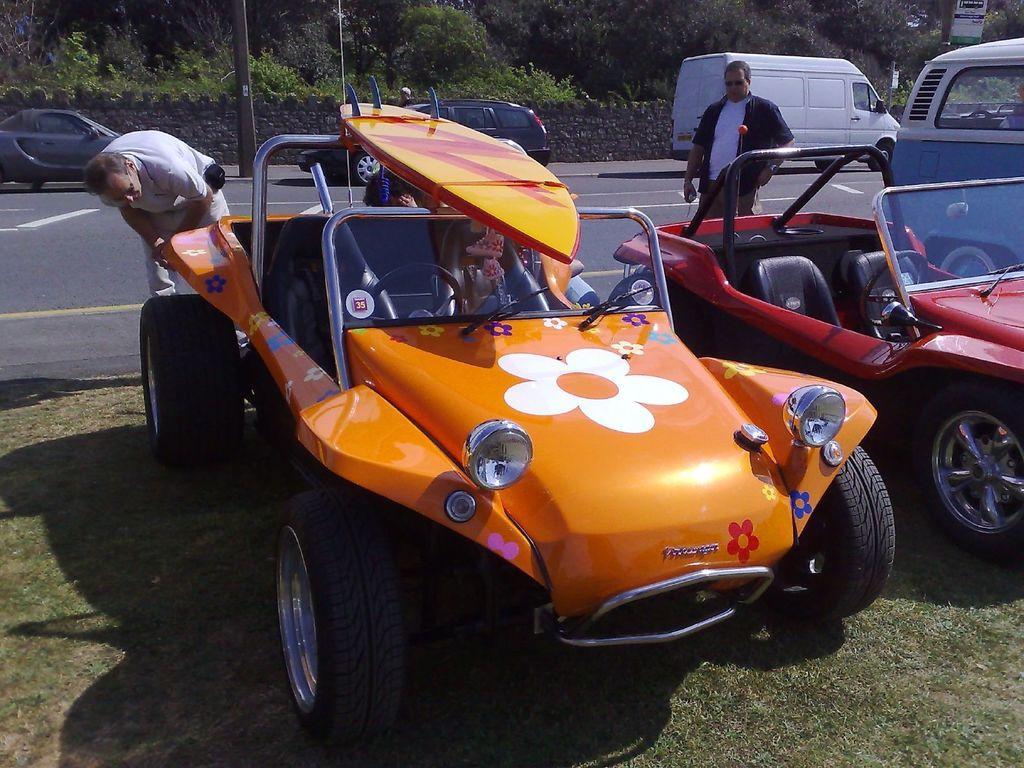Can you describe this image briefly? There are vehicles on the grass on the ground. In the background there are few persons standing, vehicles on the road, poles, wall, plants, trees and hoardings on the right side. 